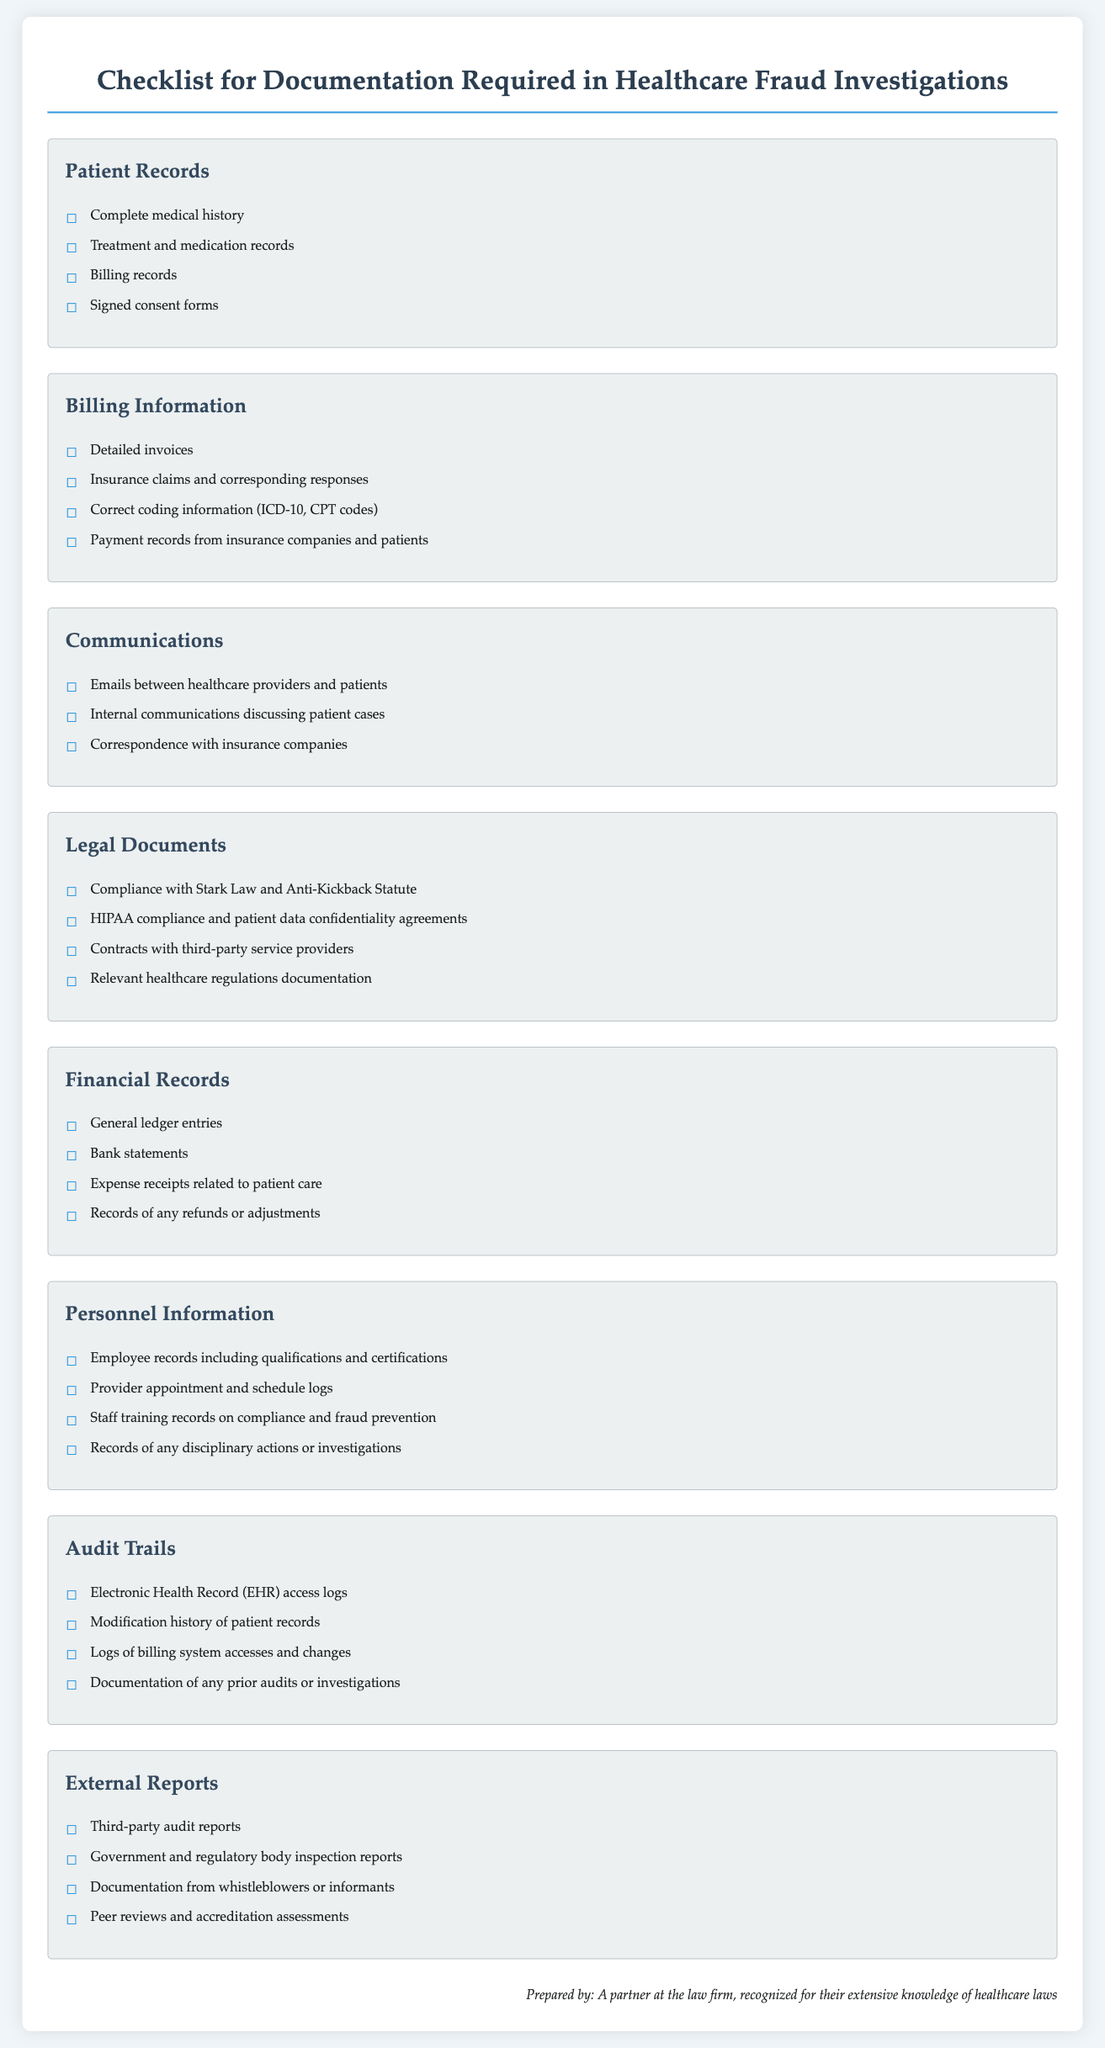what is included in the patient records section? The patient records section includes a list of documentation required for healthcare fraud investigations: complete medical history, treatment and medication records, billing records, and signed consent forms.
Answer: complete medical history, treatment and medication records, billing records, signed consent forms how many items are listed under billing information? The billing information section lists four items necessary for documentation in healthcare fraud investigations.
Answer: 4 what type of compliance is mentioned in the legal documents section? The legal documents section mentions compliance with specific laws and regulations relevant to healthcare fraud investigations.
Answer: Stark Law and Anti-Kickback Statute which records are necessary for personnel information? Personnel information section specifies the documentation related to employee qualifications, schedules, training records, and disciplinary actions.
Answer: Employee records including qualifications and certifications, provider appointment and schedule logs, staff training records on compliance and fraud prevention, records of any disciplinary actions or investigations how many sections are included in the checklist? The checklist includes multiple sections designed to organize the documentation needed for healthcare fraud investigations.
Answer: 8 